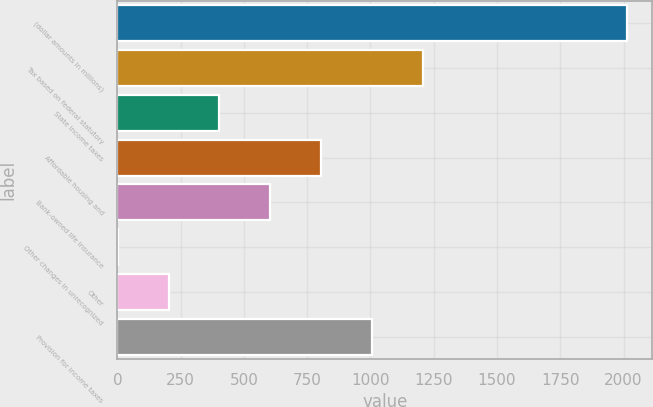Convert chart to OTSL. <chart><loc_0><loc_0><loc_500><loc_500><bar_chart><fcel>(dollar amounts in millions)<fcel>Tax based on federal statutory<fcel>State income taxes<fcel>Affordable housing and<fcel>Bank-owned life insurance<fcel>Other changes in unrecognized<fcel>Other<fcel>Provision for income taxes<nl><fcel>2012<fcel>1207.6<fcel>403.2<fcel>805.4<fcel>604.3<fcel>1<fcel>202.1<fcel>1006.5<nl></chart> 